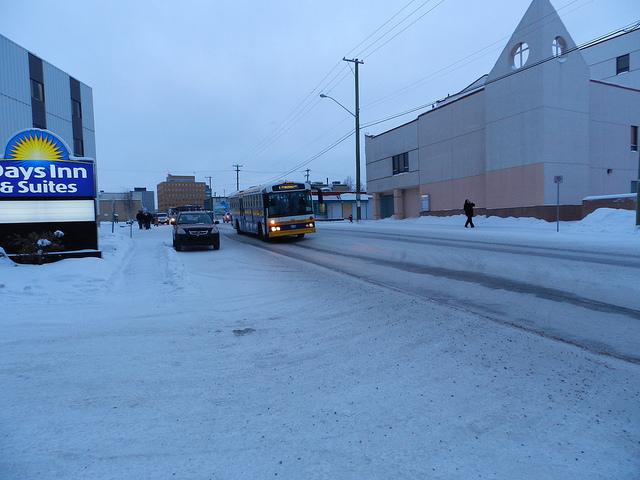What season is it?
Be succinct. Winter. How many stars does the hotel likely have?
Short answer required. 2. What kind of vehicle has their lights on?
Write a very short answer. Bus. 